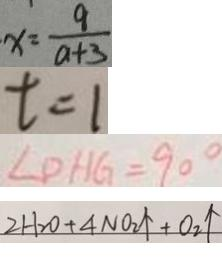Convert formula to latex. <formula><loc_0><loc_0><loc_500><loc_500>x = \frac { 9 } { a + 3 } 
 t = 1 
 \angle D H G = 9 0 ^ { \circ } 
 2 H _ { 2 } O + 4 N O _ { 2 } \uparrow + O _ { 2 } \uparrow</formula> 